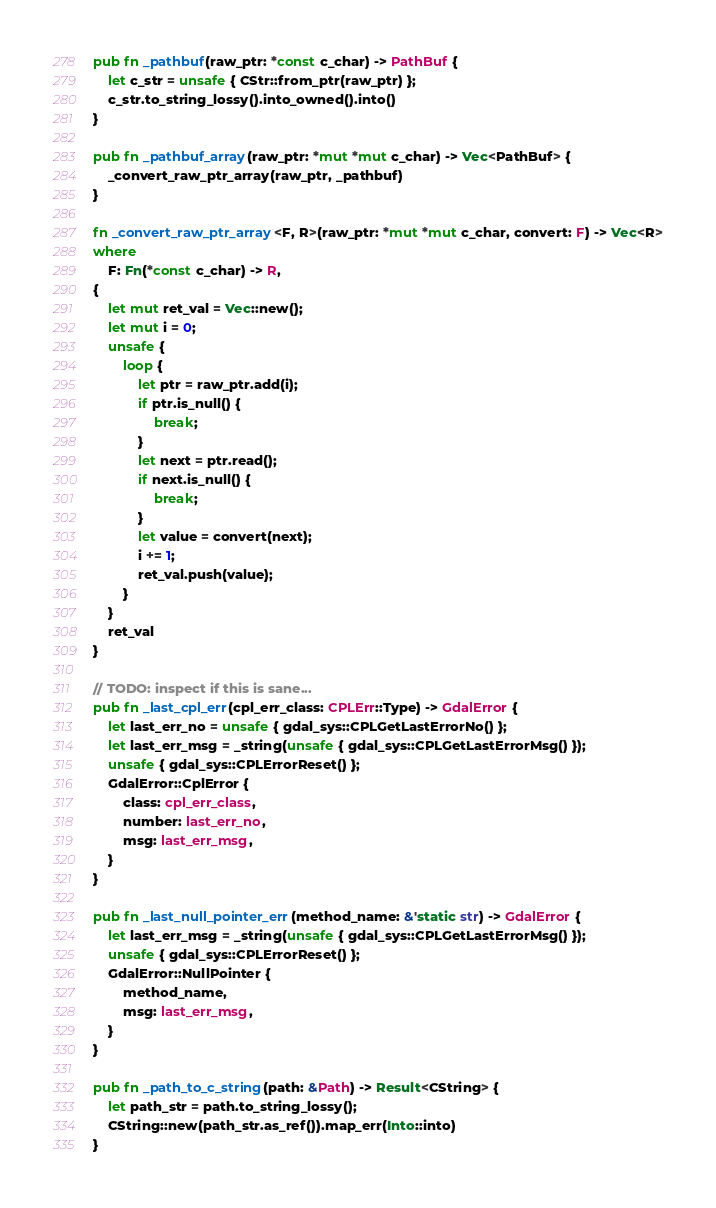<code> <loc_0><loc_0><loc_500><loc_500><_Rust_>pub fn _pathbuf(raw_ptr: *const c_char) -> PathBuf {
    let c_str = unsafe { CStr::from_ptr(raw_ptr) };
    c_str.to_string_lossy().into_owned().into()
}

pub fn _pathbuf_array(raw_ptr: *mut *mut c_char) -> Vec<PathBuf> {
    _convert_raw_ptr_array(raw_ptr, _pathbuf)
}

fn _convert_raw_ptr_array<F, R>(raw_ptr: *mut *mut c_char, convert: F) -> Vec<R>
where
    F: Fn(*const c_char) -> R,
{
    let mut ret_val = Vec::new();
    let mut i = 0;
    unsafe {
        loop {
            let ptr = raw_ptr.add(i);
            if ptr.is_null() {
                break;
            }
            let next = ptr.read();
            if next.is_null() {
                break;
            }
            let value = convert(next);
            i += 1;
            ret_val.push(value);
        }
    }
    ret_val
}

// TODO: inspect if this is sane...
pub fn _last_cpl_err(cpl_err_class: CPLErr::Type) -> GdalError {
    let last_err_no = unsafe { gdal_sys::CPLGetLastErrorNo() };
    let last_err_msg = _string(unsafe { gdal_sys::CPLGetLastErrorMsg() });
    unsafe { gdal_sys::CPLErrorReset() };
    GdalError::CplError {
        class: cpl_err_class,
        number: last_err_no,
        msg: last_err_msg,
    }
}

pub fn _last_null_pointer_err(method_name: &'static str) -> GdalError {
    let last_err_msg = _string(unsafe { gdal_sys::CPLGetLastErrorMsg() });
    unsafe { gdal_sys::CPLErrorReset() };
    GdalError::NullPointer {
        method_name,
        msg: last_err_msg,
    }
}

pub fn _path_to_c_string(path: &Path) -> Result<CString> {
    let path_str = path.to_string_lossy();
    CString::new(path_str.as_ref()).map_err(Into::into)
}
</code> 